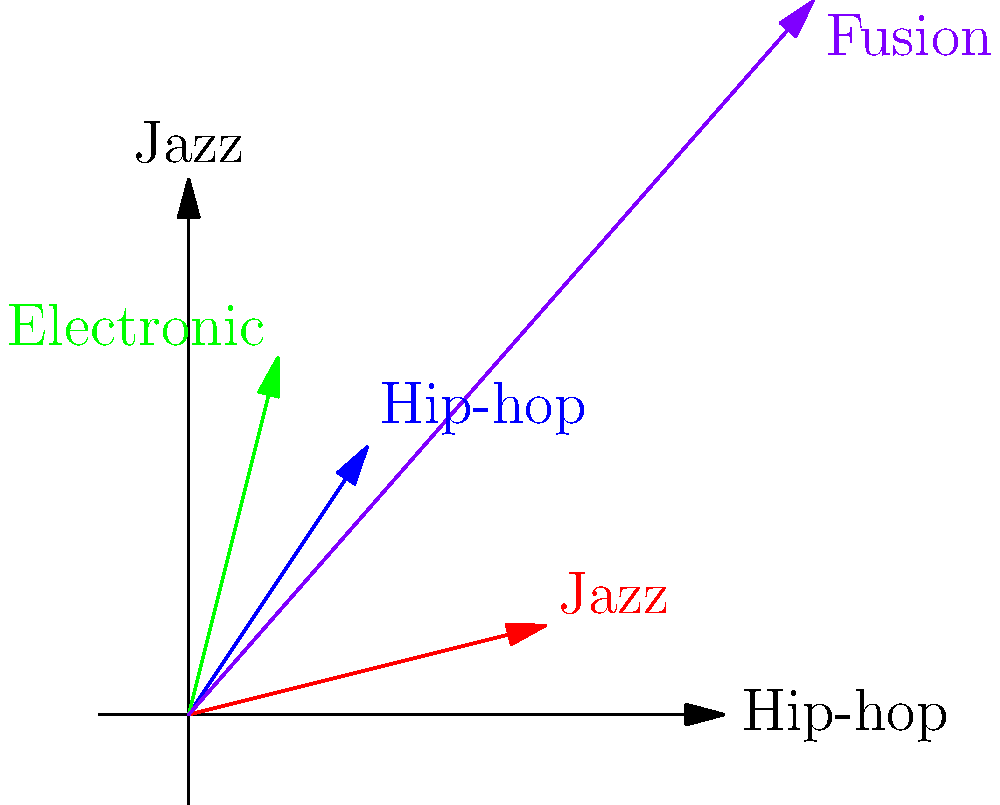As a hip-hop producer inspired by genre fusion, you're experimenting with combining vector representations of different music genres. Given the vector representations for hip-hop (2, 3), jazz (4, 1), and electronic (1, 4) in a two-dimensional space where the x-axis represents elements of hip-hop and the y-axis represents elements of jazz, what would be the resulting vector coordinates for a fusion style that equally incorporates all three genres? To find the vector coordinates for a fusion style that equally incorporates hip-hop, jazz, and electronic genres, we need to follow these steps:

1. Identify the given vector coordinates:
   Hip-hop: (2, 3)
   Jazz: (4, 1)
   Electronic: (1, 4)

2. To combine these vectors equally, we need to add them together:
   Fusion = Hip-hop + Jazz + Electronic

3. Add the x-coordinates:
   x = 2 + 4 + 1 = 7

4. Add the y-coordinates:
   y = 3 + 1 + 4 = 8

5. The resulting vector for the fusion style is (7, 8).

This vector represents a new style that combines elements from all three genres. The x-coordinate (7) shows a strong influence of hip-hop elements, while the y-coordinate (8) indicates a significant presence of jazz elements. The electronic genre contributes to both dimensions, resulting in a well-balanced fusion of all three styles.
Answer: (7, 8) 